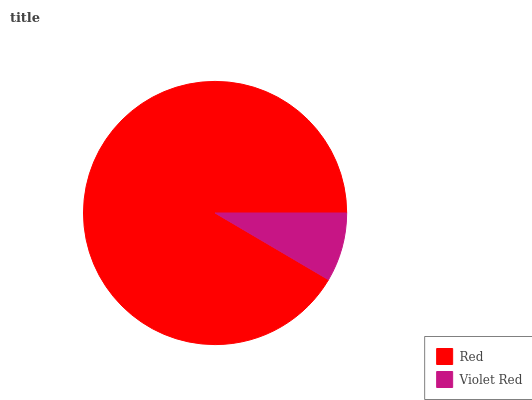Is Violet Red the minimum?
Answer yes or no. Yes. Is Red the maximum?
Answer yes or no. Yes. Is Violet Red the maximum?
Answer yes or no. No. Is Red greater than Violet Red?
Answer yes or no. Yes. Is Violet Red less than Red?
Answer yes or no. Yes. Is Violet Red greater than Red?
Answer yes or no. No. Is Red less than Violet Red?
Answer yes or no. No. Is Red the high median?
Answer yes or no. Yes. Is Violet Red the low median?
Answer yes or no. Yes. Is Violet Red the high median?
Answer yes or no. No. Is Red the low median?
Answer yes or no. No. 